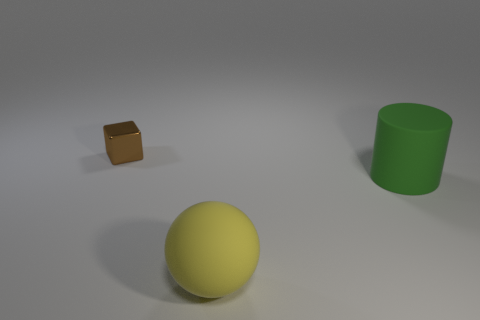Subtract all cyan spheres. Subtract all cyan cubes. How many spheres are left? 1 Add 3 purple objects. How many objects exist? 6 Subtract all balls. How many objects are left? 2 Subtract 1 yellow balls. How many objects are left? 2 Subtract all blocks. Subtract all large red rubber balls. How many objects are left? 2 Add 2 large green matte cylinders. How many large green matte cylinders are left? 3 Add 3 tiny brown objects. How many tiny brown objects exist? 4 